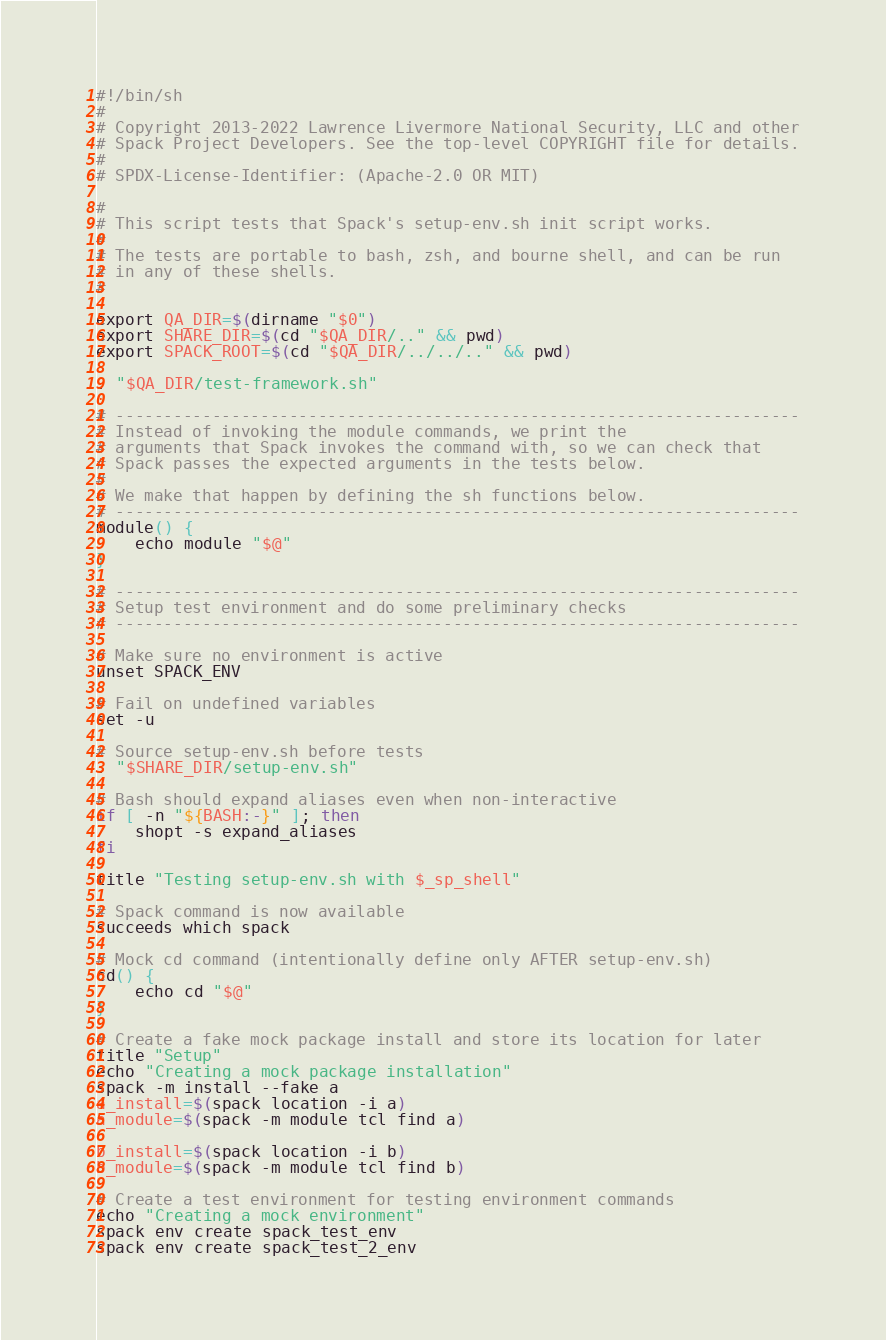Convert code to text. <code><loc_0><loc_0><loc_500><loc_500><_Bash_>#!/bin/sh
#
# Copyright 2013-2022 Lawrence Livermore National Security, LLC and other
# Spack Project Developers. See the top-level COPYRIGHT file for details.
#
# SPDX-License-Identifier: (Apache-2.0 OR MIT)

#
# This script tests that Spack's setup-env.sh init script works.
#
# The tests are portable to bash, zsh, and bourne shell, and can be run
# in any of these shells.
#

export QA_DIR=$(dirname "$0")
export SHARE_DIR=$(cd "$QA_DIR/.." && pwd)
export SPACK_ROOT=$(cd "$QA_DIR/../../.." && pwd)

. "$QA_DIR/test-framework.sh"

# -----------------------------------------------------------------------
# Instead of invoking the module commands, we print the
# arguments that Spack invokes the command with, so we can check that
# Spack passes the expected arguments in the tests below.
#
# We make that happen by defining the sh functions below.
# -----------------------------------------------------------------------
module() {
    echo module "$@"
}

# -----------------------------------------------------------------------
# Setup test environment and do some preliminary checks
# -----------------------------------------------------------------------

# Make sure no environment is active
unset SPACK_ENV

# Fail on undefined variables
set -u

# Source setup-env.sh before tests
. "$SHARE_DIR/setup-env.sh"

# Bash should expand aliases even when non-interactive
if [ -n "${BASH:-}" ]; then
    shopt -s expand_aliases
fi

title "Testing setup-env.sh with $_sp_shell"

# Spack command is now available
succeeds which spack

# Mock cd command (intentionally define only AFTER setup-env.sh)
cd() {
    echo cd "$@"
}

# Create a fake mock package install and store its location for later
title "Setup"
echo "Creating a mock package installation"
spack -m install --fake a
a_install=$(spack location -i a)
a_module=$(spack -m module tcl find a)

b_install=$(spack location -i b)
b_module=$(spack -m module tcl find b)

# Create a test environment for testing environment commands
echo "Creating a mock environment"
spack env create spack_test_env
spack env create spack_test_2_env
</code> 